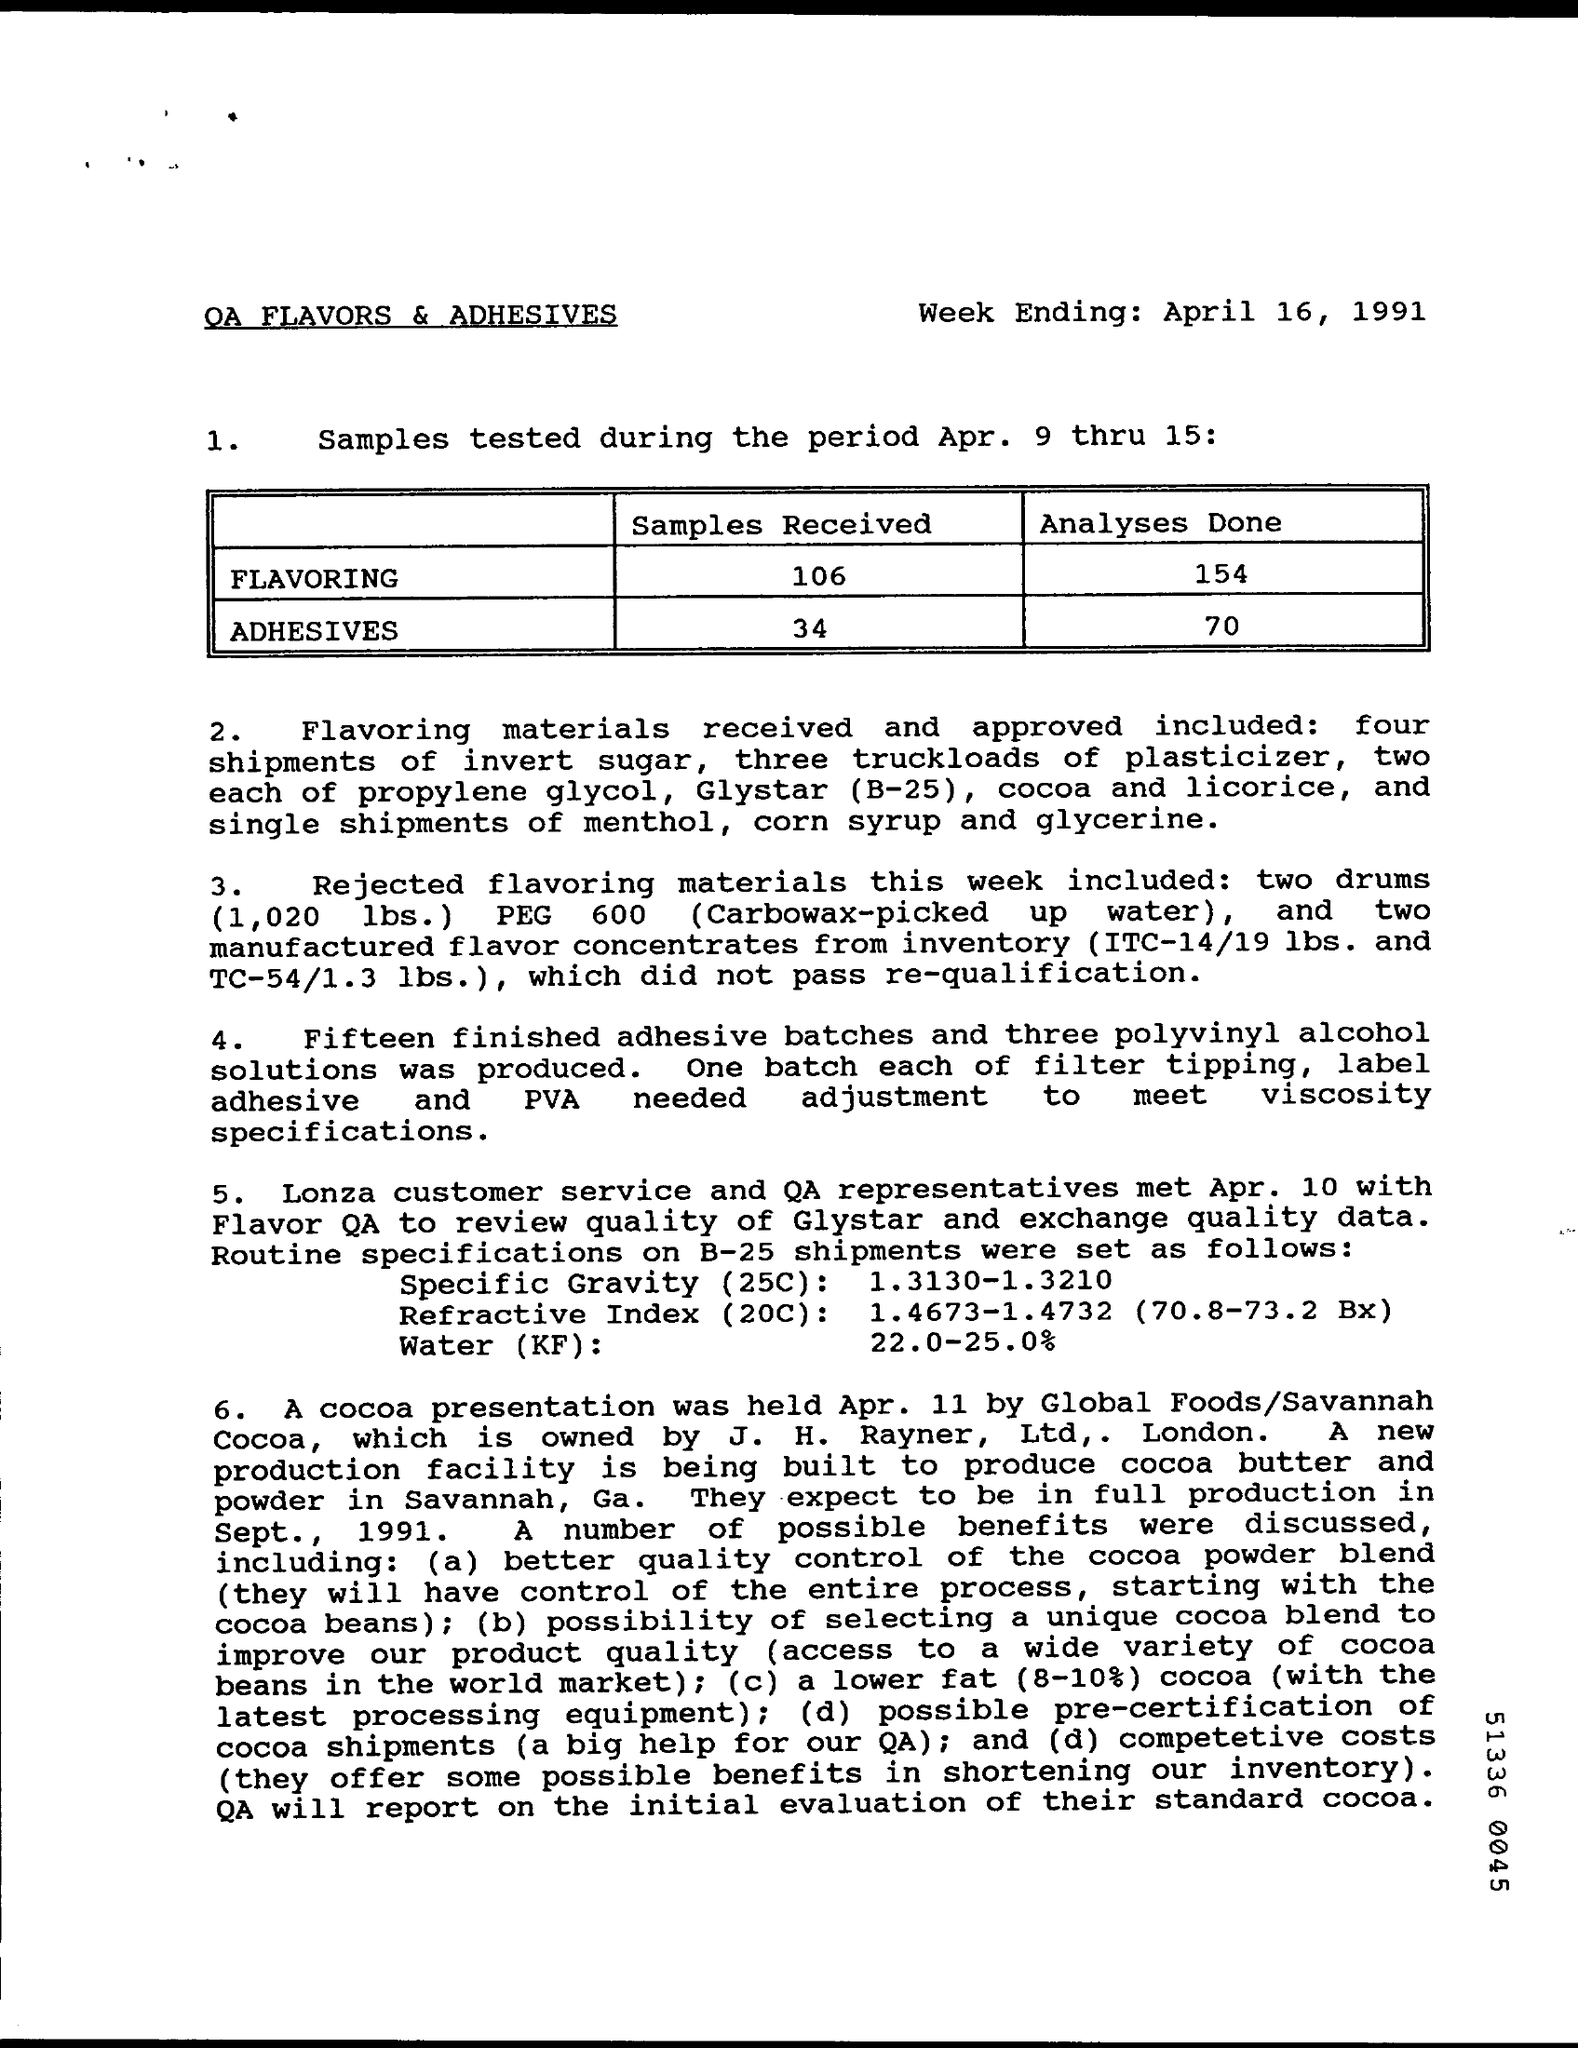Specify some key components in this picture. When is the week ending for April 16, 1991? Cocoa presentation was held on April 11th. A total of 106 samples were received for the flavoring analysis. 